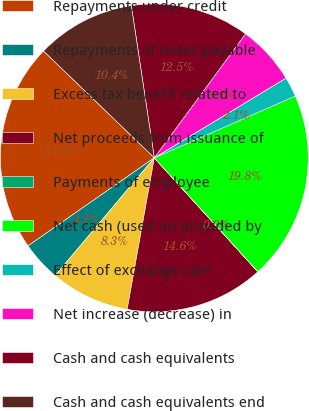Convert chart. <chart><loc_0><loc_0><loc_500><loc_500><pie_chart><fcel>Repayments under credit<fcel>Repayments of notes payable<fcel>Excess tax benefit related to<fcel>Net proceeds from issuance of<fcel>Payments of employee<fcel>Net cash (used in) provided by<fcel>Effect of exchange rate<fcel>Net increase (decrease) in<fcel>Cash and cash equivalents<fcel>Cash and cash equivalents end<nl><fcel>21.9%<fcel>4.17%<fcel>8.32%<fcel>14.56%<fcel>0.01%<fcel>19.82%<fcel>2.09%<fcel>6.24%<fcel>12.48%<fcel>10.4%<nl></chart> 